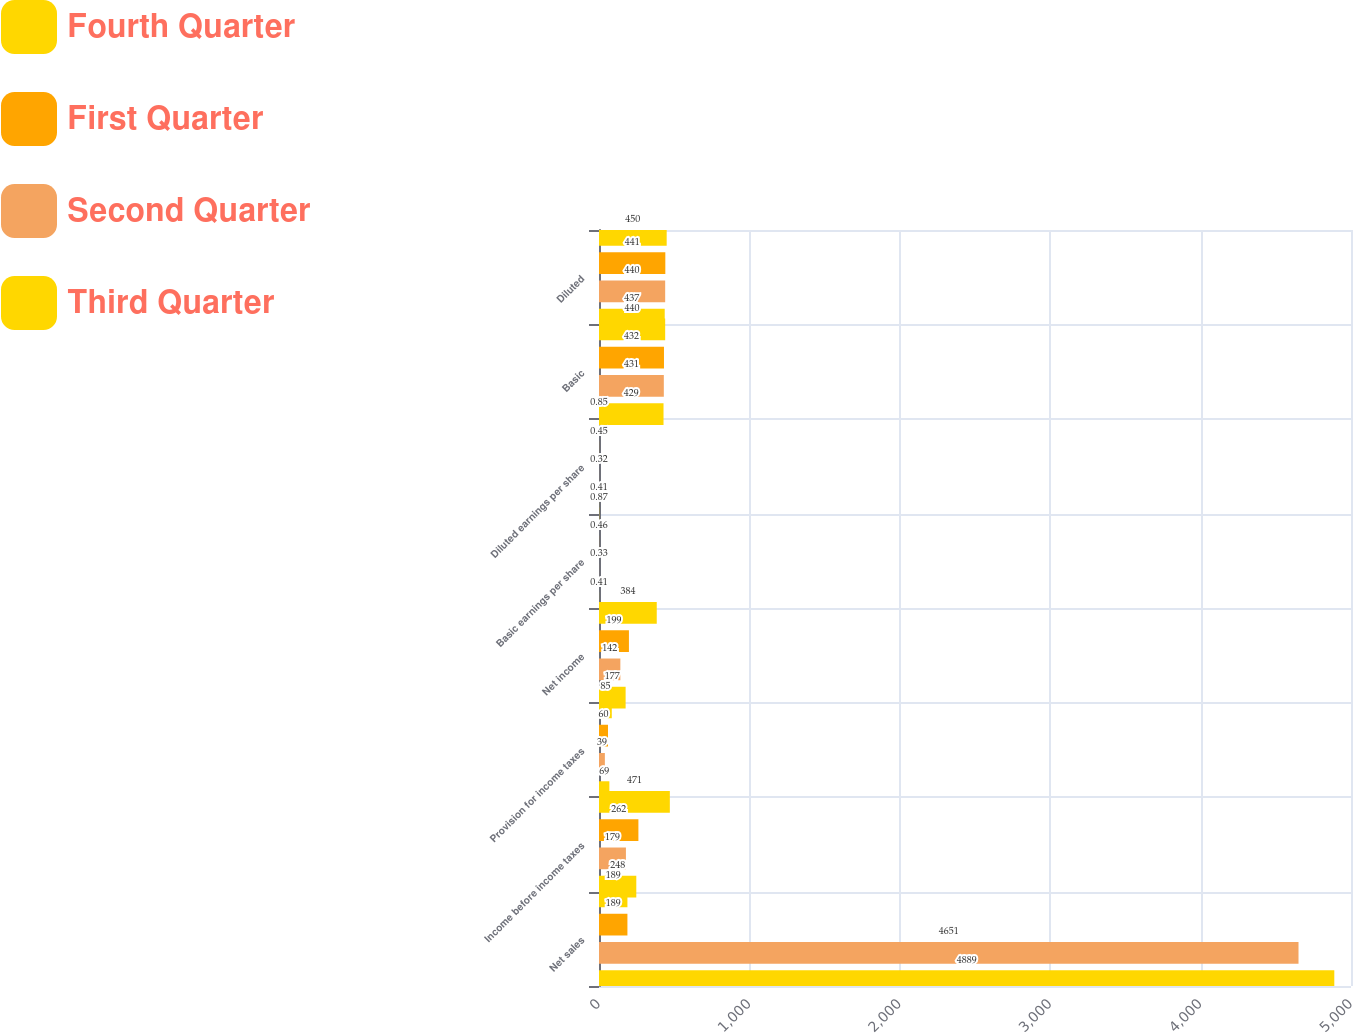<chart> <loc_0><loc_0><loc_500><loc_500><stacked_bar_chart><ecel><fcel>Net sales<fcel>Income before income taxes<fcel>Provision for income taxes<fcel>Net income<fcel>Basic earnings per share<fcel>Diluted earnings per share<fcel>Basic<fcel>Diluted<nl><fcel>Fourth Quarter<fcel>189<fcel>471<fcel>85<fcel>384<fcel>0.87<fcel>0.85<fcel>440<fcel>450<nl><fcel>First Quarter<fcel>189<fcel>262<fcel>60<fcel>199<fcel>0.46<fcel>0.45<fcel>432<fcel>441<nl><fcel>Second Quarter<fcel>4651<fcel>179<fcel>39<fcel>142<fcel>0.33<fcel>0.32<fcel>431<fcel>440<nl><fcel>Third Quarter<fcel>4889<fcel>248<fcel>69<fcel>177<fcel>0.41<fcel>0.41<fcel>429<fcel>437<nl></chart> 